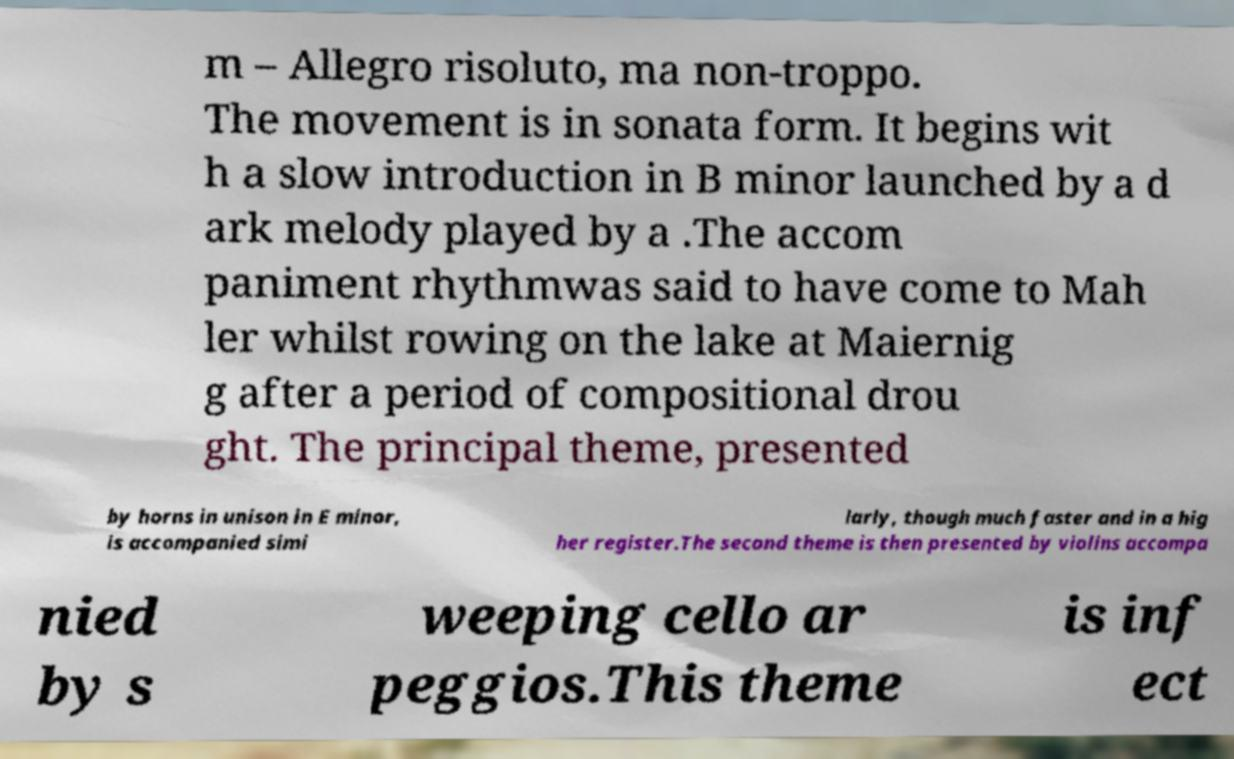Can you accurately transcribe the text from the provided image for me? m – Allegro risoluto, ma non-troppo. The movement is in sonata form. It begins wit h a slow introduction in B minor launched by a d ark melody played by a .The accom paniment rhythmwas said to have come to Mah ler whilst rowing on the lake at Maiernig g after a period of compositional drou ght. The principal theme, presented by horns in unison in E minor, is accompanied simi larly, though much faster and in a hig her register.The second theme is then presented by violins accompa nied by s weeping cello ar peggios.This theme is inf ect 